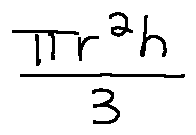Convert formula to latex. <formula><loc_0><loc_0><loc_500><loc_500>\frac { \pi r ^ { 2 } h } { 3 }</formula> 